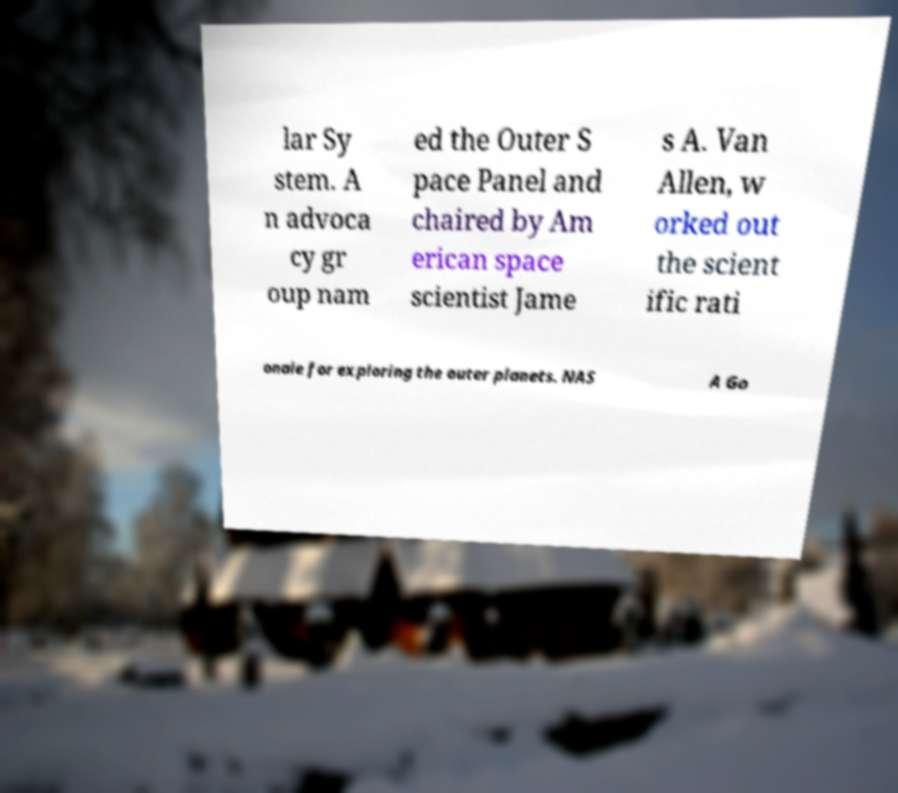Could you extract and type out the text from this image? lar Sy stem. A n advoca cy gr oup nam ed the Outer S pace Panel and chaired by Am erican space scientist Jame s A. Van Allen, w orked out the scient ific rati onale for exploring the outer planets. NAS A Go 